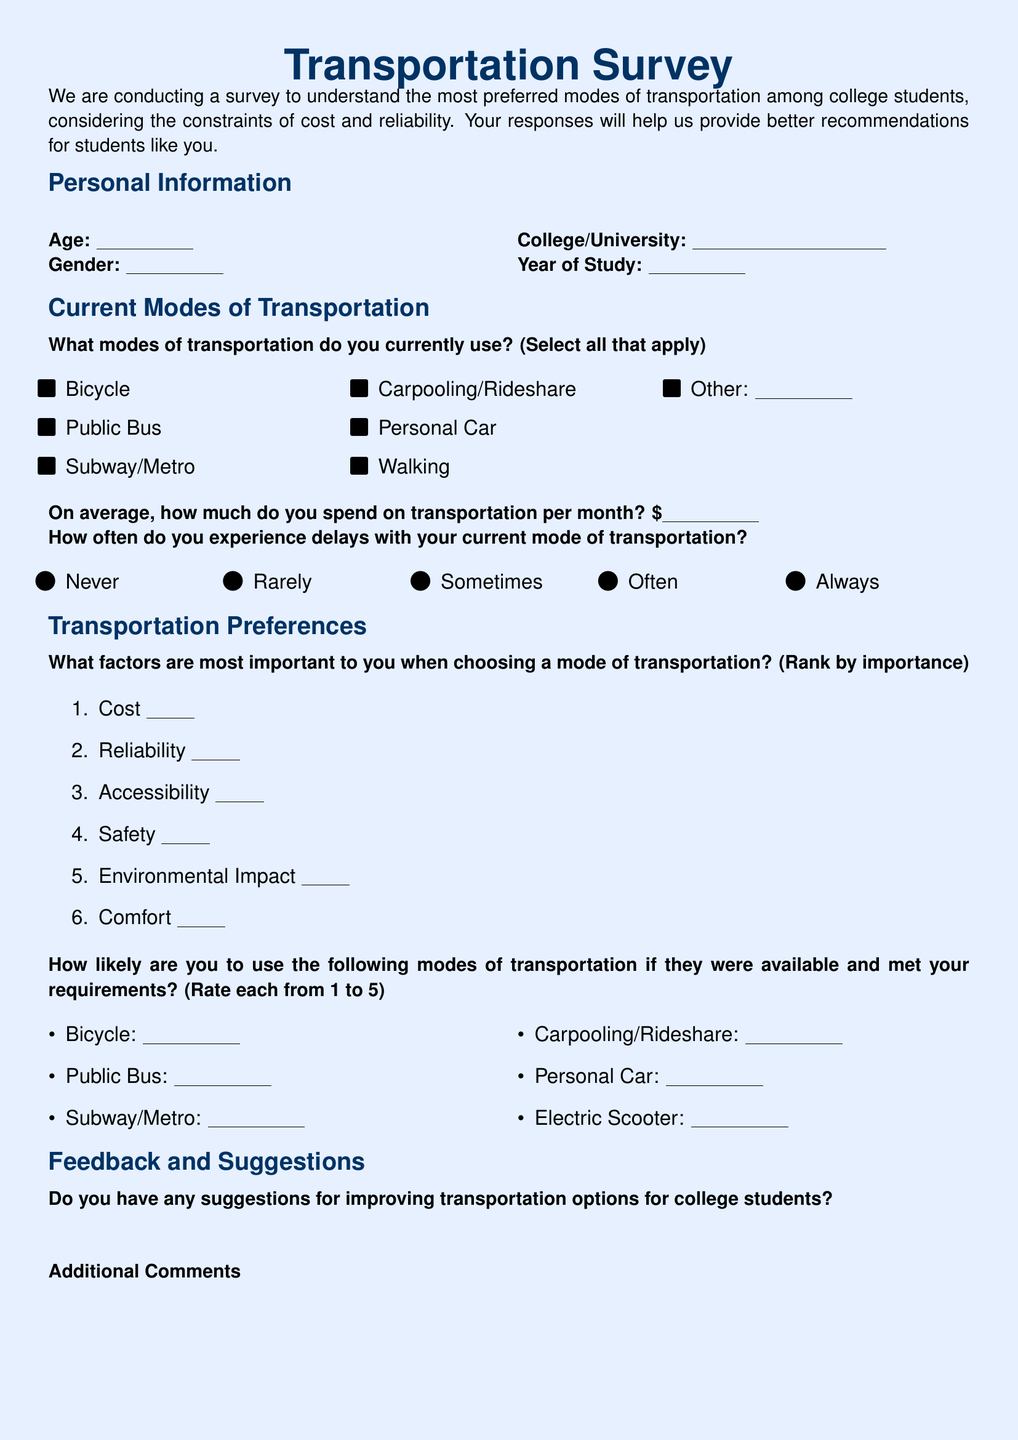What is the title of the survey? The title is prominently displayed in the document as a heading.
Answer: Transportation Survey How many modes of transportation can be selected? The document specifies multiple options under the current modes of transportation section.
Answer: Multiple What is the maximum spending amount asked for transportation per month? The question allows respondents to fill in a monetary amount without specifying a limit.
Answer: N/A (variable) What factor is ranked as the first in importance? The ranking list in the transportation preferences section starts with cost as the first factor.
Answer: Cost How is likelihood rated for transportation modes? The document contains a request for respondents to rate their likelihood on a scale from 1 to 5.
Answer: 1 to 5 What is the section following the 'Transportation Preferences'? The structure of the document outlines various sections, with feedback and suggestions coming after preferences.
Answer: Feedback and Suggestions What type of comments are requested at the end of the survey? The survey contains sections for suggestions and additional comments from the respondents.
Answer: Additional Comments How are the current modes of transportation presented? The document uses a checklist format to allow selections by respondents.
Answer: Checklist What is the purpose of this survey? The introductory statement clarifies the objective is to understand transportation preferences among students.
Answer: To understand preferences 